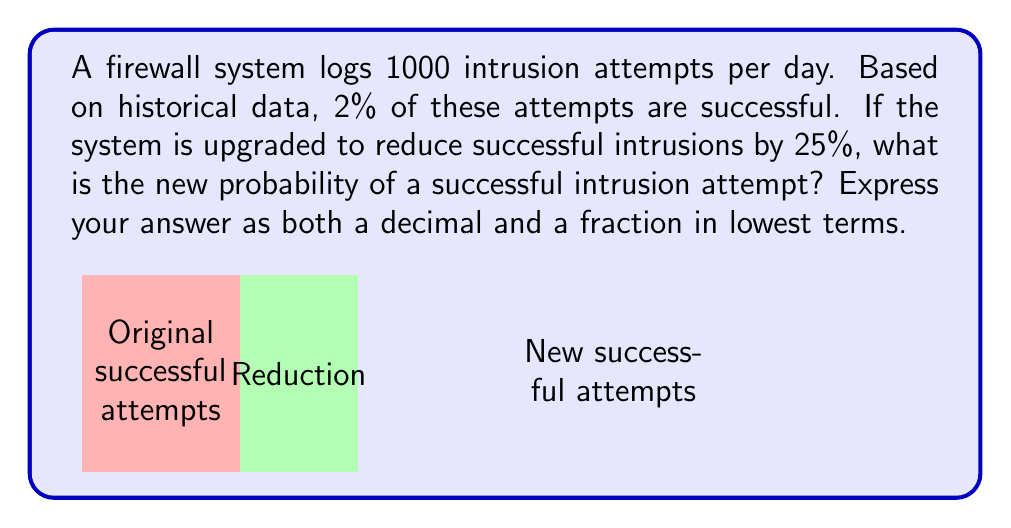Could you help me with this problem? Let's approach this step-by-step:

1) Initially, the probability of a successful intrusion is 2% or 0.02.

2) We need to reduce this by 25%. To calculate this:
   $$0.02 \times 0.25 = 0.005$$

3) The new probability will be the original probability minus this reduction:
   $$0.02 - 0.005 = 0.015$$

4) To express this as a fraction, we can write:
   $$\frac{15}{1000}$$

5) To simplify this fraction, we divide both numerator and denominator by their greatest common divisor (5):
   $$\frac{15 \div 5}{1000 \div 5} = \frac{3}{200}$$

Therefore, the new probability is 0.015 as a decimal, or $\frac{3}{200}$ as a fraction in lowest terms.
Answer: 0.015 or $\frac{3}{200}$ 